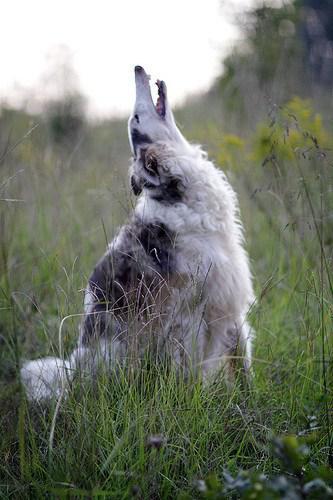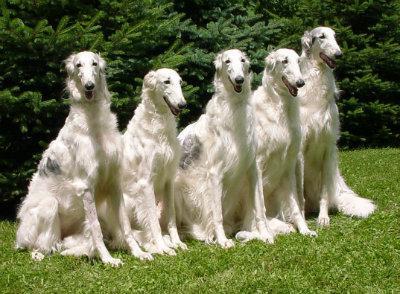The first image is the image on the left, the second image is the image on the right. Considering the images on both sides, is "There are the same number of hounds in the left and right images." valid? Answer yes or no. No. The first image is the image on the left, the second image is the image on the right. Evaluate the accuracy of this statement regarding the images: "There is a dog in the center of both images.". Is it true? Answer yes or no. Yes. The first image is the image on the left, the second image is the image on the right. Examine the images to the left and right. Is the description "There are no more than 2 dogs per image pair" accurate? Answer yes or no. No. 